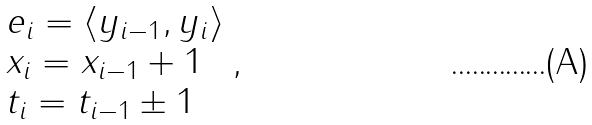<formula> <loc_0><loc_0><loc_500><loc_500>\begin{array} { l } e _ { i } = \langle y _ { i - 1 } , y _ { i } \rangle \\ x _ { i } = x _ { i - 1 } + 1 \\ t _ { i } = t _ { i - 1 } \pm 1 \end{array} ,</formula> 